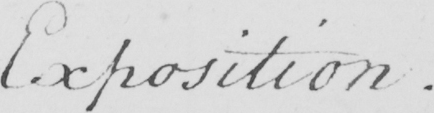What is written in this line of handwriting? Exposition 